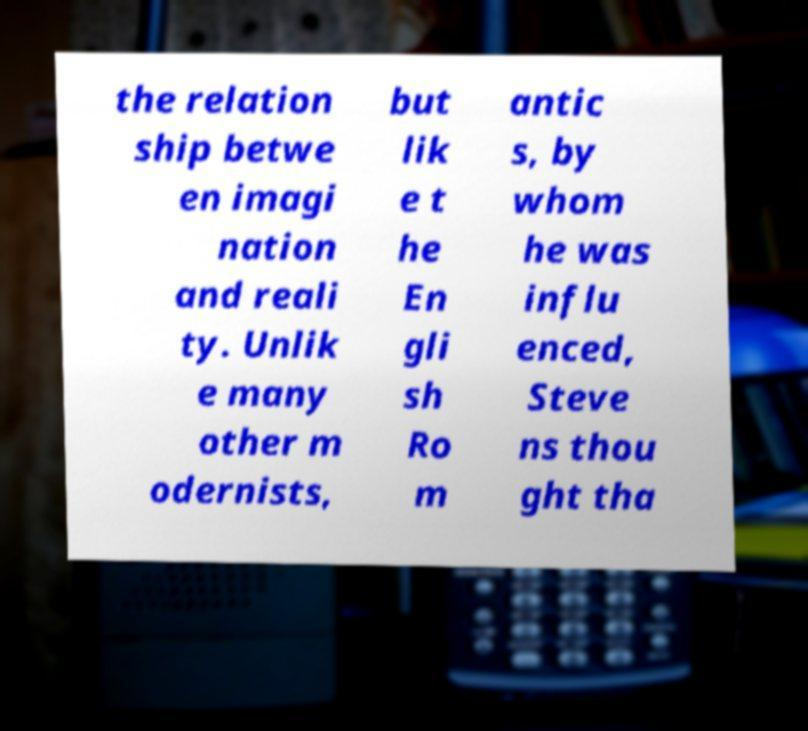What messages or text are displayed in this image? I need them in a readable, typed format. the relation ship betwe en imagi nation and reali ty. Unlik e many other m odernists, but lik e t he En gli sh Ro m antic s, by whom he was influ enced, Steve ns thou ght tha 